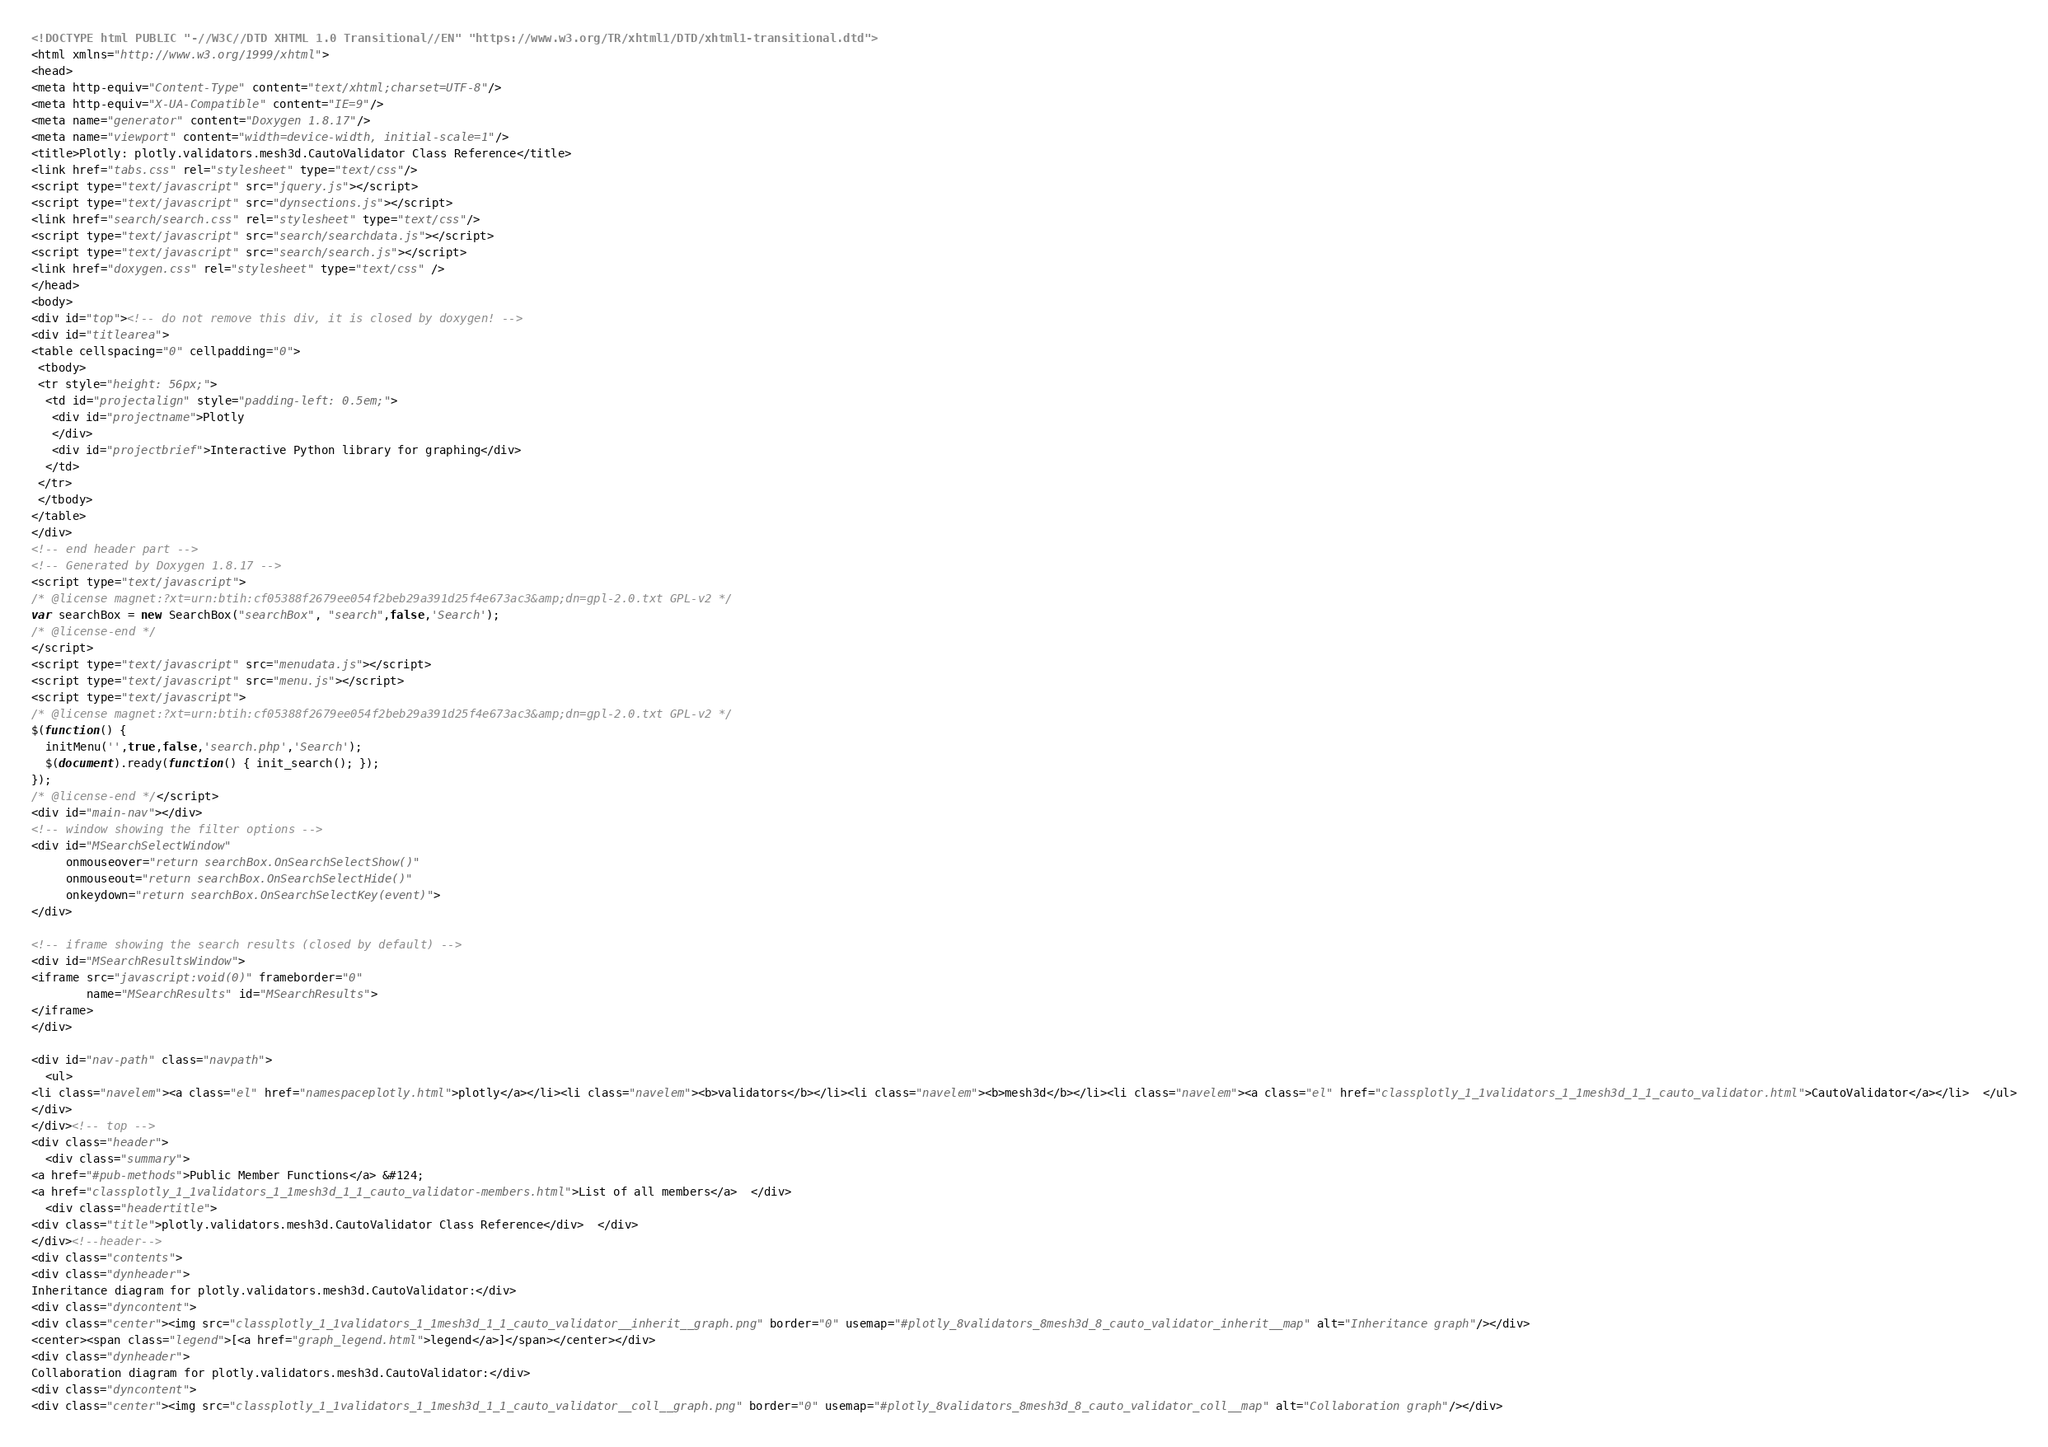Convert code to text. <code><loc_0><loc_0><loc_500><loc_500><_HTML_><!DOCTYPE html PUBLIC "-//W3C//DTD XHTML 1.0 Transitional//EN" "https://www.w3.org/TR/xhtml1/DTD/xhtml1-transitional.dtd">
<html xmlns="http://www.w3.org/1999/xhtml">
<head>
<meta http-equiv="Content-Type" content="text/xhtml;charset=UTF-8"/>
<meta http-equiv="X-UA-Compatible" content="IE=9"/>
<meta name="generator" content="Doxygen 1.8.17"/>
<meta name="viewport" content="width=device-width, initial-scale=1"/>
<title>Plotly: plotly.validators.mesh3d.CautoValidator Class Reference</title>
<link href="tabs.css" rel="stylesheet" type="text/css"/>
<script type="text/javascript" src="jquery.js"></script>
<script type="text/javascript" src="dynsections.js"></script>
<link href="search/search.css" rel="stylesheet" type="text/css"/>
<script type="text/javascript" src="search/searchdata.js"></script>
<script type="text/javascript" src="search/search.js"></script>
<link href="doxygen.css" rel="stylesheet" type="text/css" />
</head>
<body>
<div id="top"><!-- do not remove this div, it is closed by doxygen! -->
<div id="titlearea">
<table cellspacing="0" cellpadding="0">
 <tbody>
 <tr style="height: 56px;">
  <td id="projectalign" style="padding-left: 0.5em;">
   <div id="projectname">Plotly
   </div>
   <div id="projectbrief">Interactive Python library for graphing</div>
  </td>
 </tr>
 </tbody>
</table>
</div>
<!-- end header part -->
<!-- Generated by Doxygen 1.8.17 -->
<script type="text/javascript">
/* @license magnet:?xt=urn:btih:cf05388f2679ee054f2beb29a391d25f4e673ac3&amp;dn=gpl-2.0.txt GPL-v2 */
var searchBox = new SearchBox("searchBox", "search",false,'Search');
/* @license-end */
</script>
<script type="text/javascript" src="menudata.js"></script>
<script type="text/javascript" src="menu.js"></script>
<script type="text/javascript">
/* @license magnet:?xt=urn:btih:cf05388f2679ee054f2beb29a391d25f4e673ac3&amp;dn=gpl-2.0.txt GPL-v2 */
$(function() {
  initMenu('',true,false,'search.php','Search');
  $(document).ready(function() { init_search(); });
});
/* @license-end */</script>
<div id="main-nav"></div>
<!-- window showing the filter options -->
<div id="MSearchSelectWindow"
     onmouseover="return searchBox.OnSearchSelectShow()"
     onmouseout="return searchBox.OnSearchSelectHide()"
     onkeydown="return searchBox.OnSearchSelectKey(event)">
</div>

<!-- iframe showing the search results (closed by default) -->
<div id="MSearchResultsWindow">
<iframe src="javascript:void(0)" frameborder="0" 
        name="MSearchResults" id="MSearchResults">
</iframe>
</div>

<div id="nav-path" class="navpath">
  <ul>
<li class="navelem"><a class="el" href="namespaceplotly.html">plotly</a></li><li class="navelem"><b>validators</b></li><li class="navelem"><b>mesh3d</b></li><li class="navelem"><a class="el" href="classplotly_1_1validators_1_1mesh3d_1_1_cauto_validator.html">CautoValidator</a></li>  </ul>
</div>
</div><!-- top -->
<div class="header">
  <div class="summary">
<a href="#pub-methods">Public Member Functions</a> &#124;
<a href="classplotly_1_1validators_1_1mesh3d_1_1_cauto_validator-members.html">List of all members</a>  </div>
  <div class="headertitle">
<div class="title">plotly.validators.mesh3d.CautoValidator Class Reference</div>  </div>
</div><!--header-->
<div class="contents">
<div class="dynheader">
Inheritance diagram for plotly.validators.mesh3d.CautoValidator:</div>
<div class="dyncontent">
<div class="center"><img src="classplotly_1_1validators_1_1mesh3d_1_1_cauto_validator__inherit__graph.png" border="0" usemap="#plotly_8validators_8mesh3d_8_cauto_validator_inherit__map" alt="Inheritance graph"/></div>
<center><span class="legend">[<a href="graph_legend.html">legend</a>]</span></center></div>
<div class="dynheader">
Collaboration diagram for plotly.validators.mesh3d.CautoValidator:</div>
<div class="dyncontent">
<div class="center"><img src="classplotly_1_1validators_1_1mesh3d_1_1_cauto_validator__coll__graph.png" border="0" usemap="#plotly_8validators_8mesh3d_8_cauto_validator_coll__map" alt="Collaboration graph"/></div></code> 